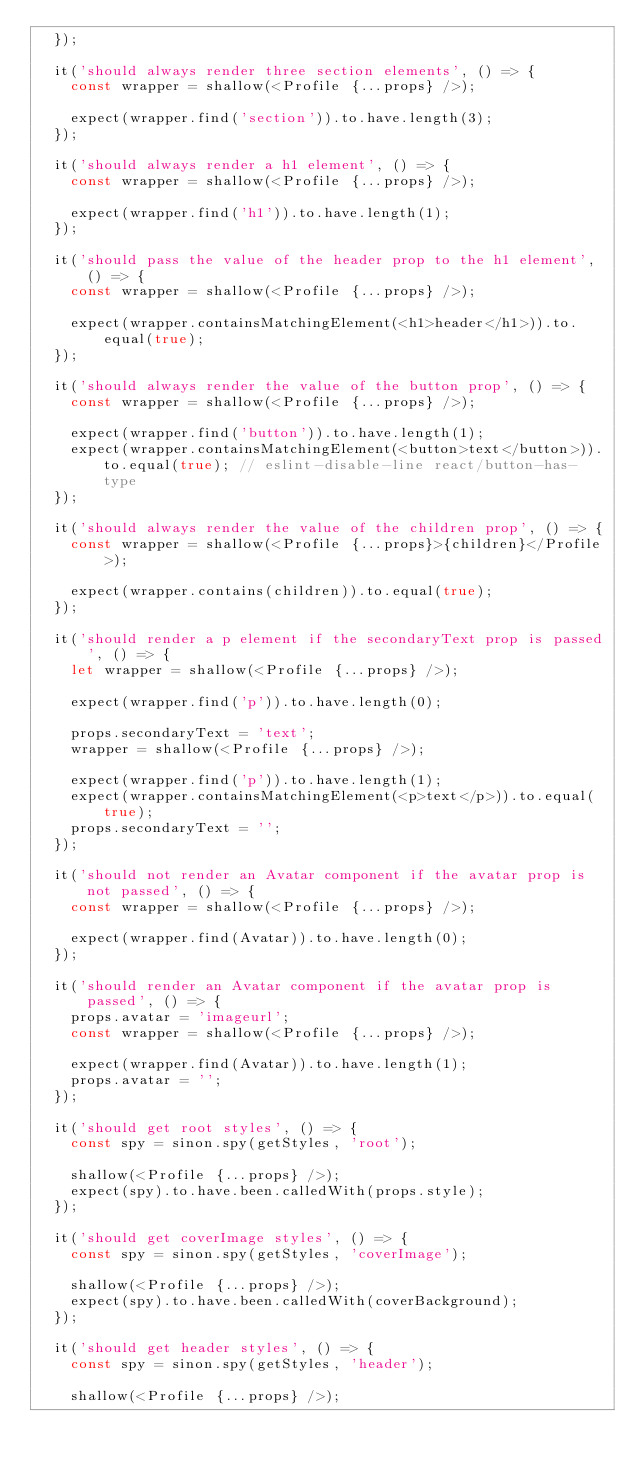Convert code to text. <code><loc_0><loc_0><loc_500><loc_500><_JavaScript_>  });

  it('should always render three section elements', () => {
    const wrapper = shallow(<Profile {...props} />);

    expect(wrapper.find('section')).to.have.length(3);
  });

  it('should always render a h1 element', () => {
    const wrapper = shallow(<Profile {...props} />);

    expect(wrapper.find('h1')).to.have.length(1);
  });

  it('should pass the value of the header prop to the h1 element', () => {
    const wrapper = shallow(<Profile {...props} />);

    expect(wrapper.containsMatchingElement(<h1>header</h1>)).to.equal(true);
  });

  it('should always render the value of the button prop', () => {
    const wrapper = shallow(<Profile {...props} />);

    expect(wrapper.find('button')).to.have.length(1);
    expect(wrapper.containsMatchingElement(<button>text</button>)).to.equal(true); // eslint-disable-line react/button-has-type
  });

  it('should always render the value of the children prop', () => {
    const wrapper = shallow(<Profile {...props}>{children}</Profile>);

    expect(wrapper.contains(children)).to.equal(true);
  });

  it('should render a p element if the secondaryText prop is passed', () => {
    let wrapper = shallow(<Profile {...props} />);

    expect(wrapper.find('p')).to.have.length(0);

    props.secondaryText = 'text';
    wrapper = shallow(<Profile {...props} />);

    expect(wrapper.find('p')).to.have.length(1);
    expect(wrapper.containsMatchingElement(<p>text</p>)).to.equal(true);
    props.secondaryText = '';
  });

  it('should not render an Avatar component if the avatar prop is not passed', () => {
    const wrapper = shallow(<Profile {...props} />);

    expect(wrapper.find(Avatar)).to.have.length(0);
  });

  it('should render an Avatar component if the avatar prop is passed', () => {
    props.avatar = 'imageurl';
    const wrapper = shallow(<Profile {...props} />);

    expect(wrapper.find(Avatar)).to.have.length(1);
    props.avatar = '';
  });

  it('should get root styles', () => {
    const spy = sinon.spy(getStyles, 'root');

    shallow(<Profile {...props} />);
    expect(spy).to.have.been.calledWith(props.style);
  });

  it('should get coverImage styles', () => {
    const spy = sinon.spy(getStyles, 'coverImage');

    shallow(<Profile {...props} />);
    expect(spy).to.have.been.calledWith(coverBackground);
  });

  it('should get header styles', () => {
    const spy = sinon.spy(getStyles, 'header');

    shallow(<Profile {...props} />);</code> 